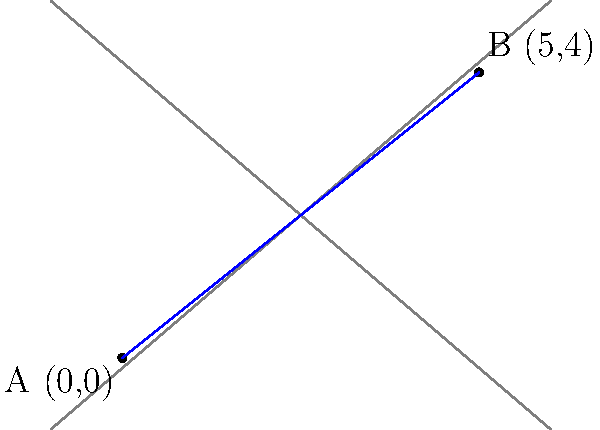In your community garden, you've planted two special varieties of tomatoes in separate plots. The coordinates of these plots on the garden grid are A(0,0) and B(5,4). Using the distance formula, calculate the shortest distance between these two tomato plots to determine how far apart they are. Round your answer to two decimal places. Let's approach this step-by-step:

1) The distance formula is derived from the Pythagorean theorem. For two points (x₁, y₁) and (x₂, y₂), the distance d is given by:

   $$d = \sqrt{(x_2 - x_1)^2 + (y_2 - y_1)^2}$$

2) In our case:
   - Point A: (x₁, y₁) = (0, 0)
   - Point B: (x₂, y₂) = (5, 4)

3) Let's substitute these values into the formula:

   $$d = \sqrt{(5 - 0)^2 + (4 - 0)^2}$$

4) Simplify:
   $$d = \sqrt{5^2 + 4^2}$$

5) Calculate the squares:
   $$d = \sqrt{25 + 16}$$

6) Add under the square root:
   $$d = \sqrt{41}$$

7) Calculate the square root:
   $$d ≈ 6.4031$$

8) Rounding to two decimal places:
   $$d ≈ 6.40$$

Therefore, the distance between the two tomato plots is approximately 6.40 units on the garden grid.
Answer: 6.40 units 